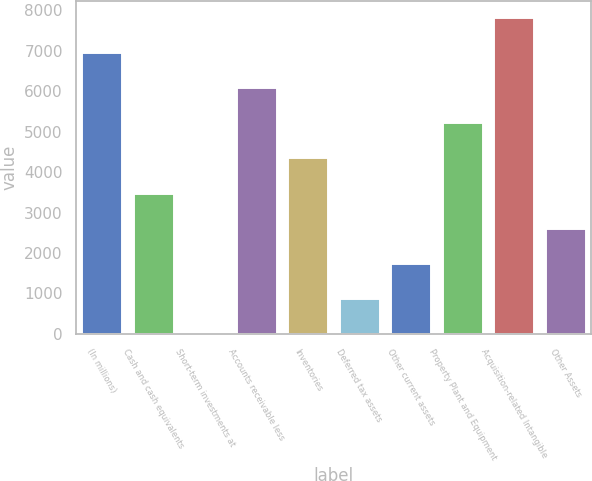<chart> <loc_0><loc_0><loc_500><loc_500><bar_chart><fcel>(In millions)<fcel>Cash and cash equivalents<fcel>Short-term investments at<fcel>Accounts receivable less<fcel>Inventories<fcel>Deferred tax assets<fcel>Other current assets<fcel>Property Plant and Equipment<fcel>Acquisition-related Intangible<fcel>Other Assets<nl><fcel>6973.38<fcel>3493.74<fcel>14.1<fcel>6103.47<fcel>4363.65<fcel>884.01<fcel>1753.92<fcel>5233.56<fcel>7843.29<fcel>2623.83<nl></chart> 